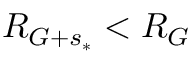<formula> <loc_0><loc_0><loc_500><loc_500>R _ { G + s _ { * } } < R _ { G }</formula> 